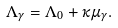<formula> <loc_0><loc_0><loc_500><loc_500>\Lambda _ { \gamma } = \Lambda _ { 0 } + \kappa \mu _ { \gamma } .</formula> 